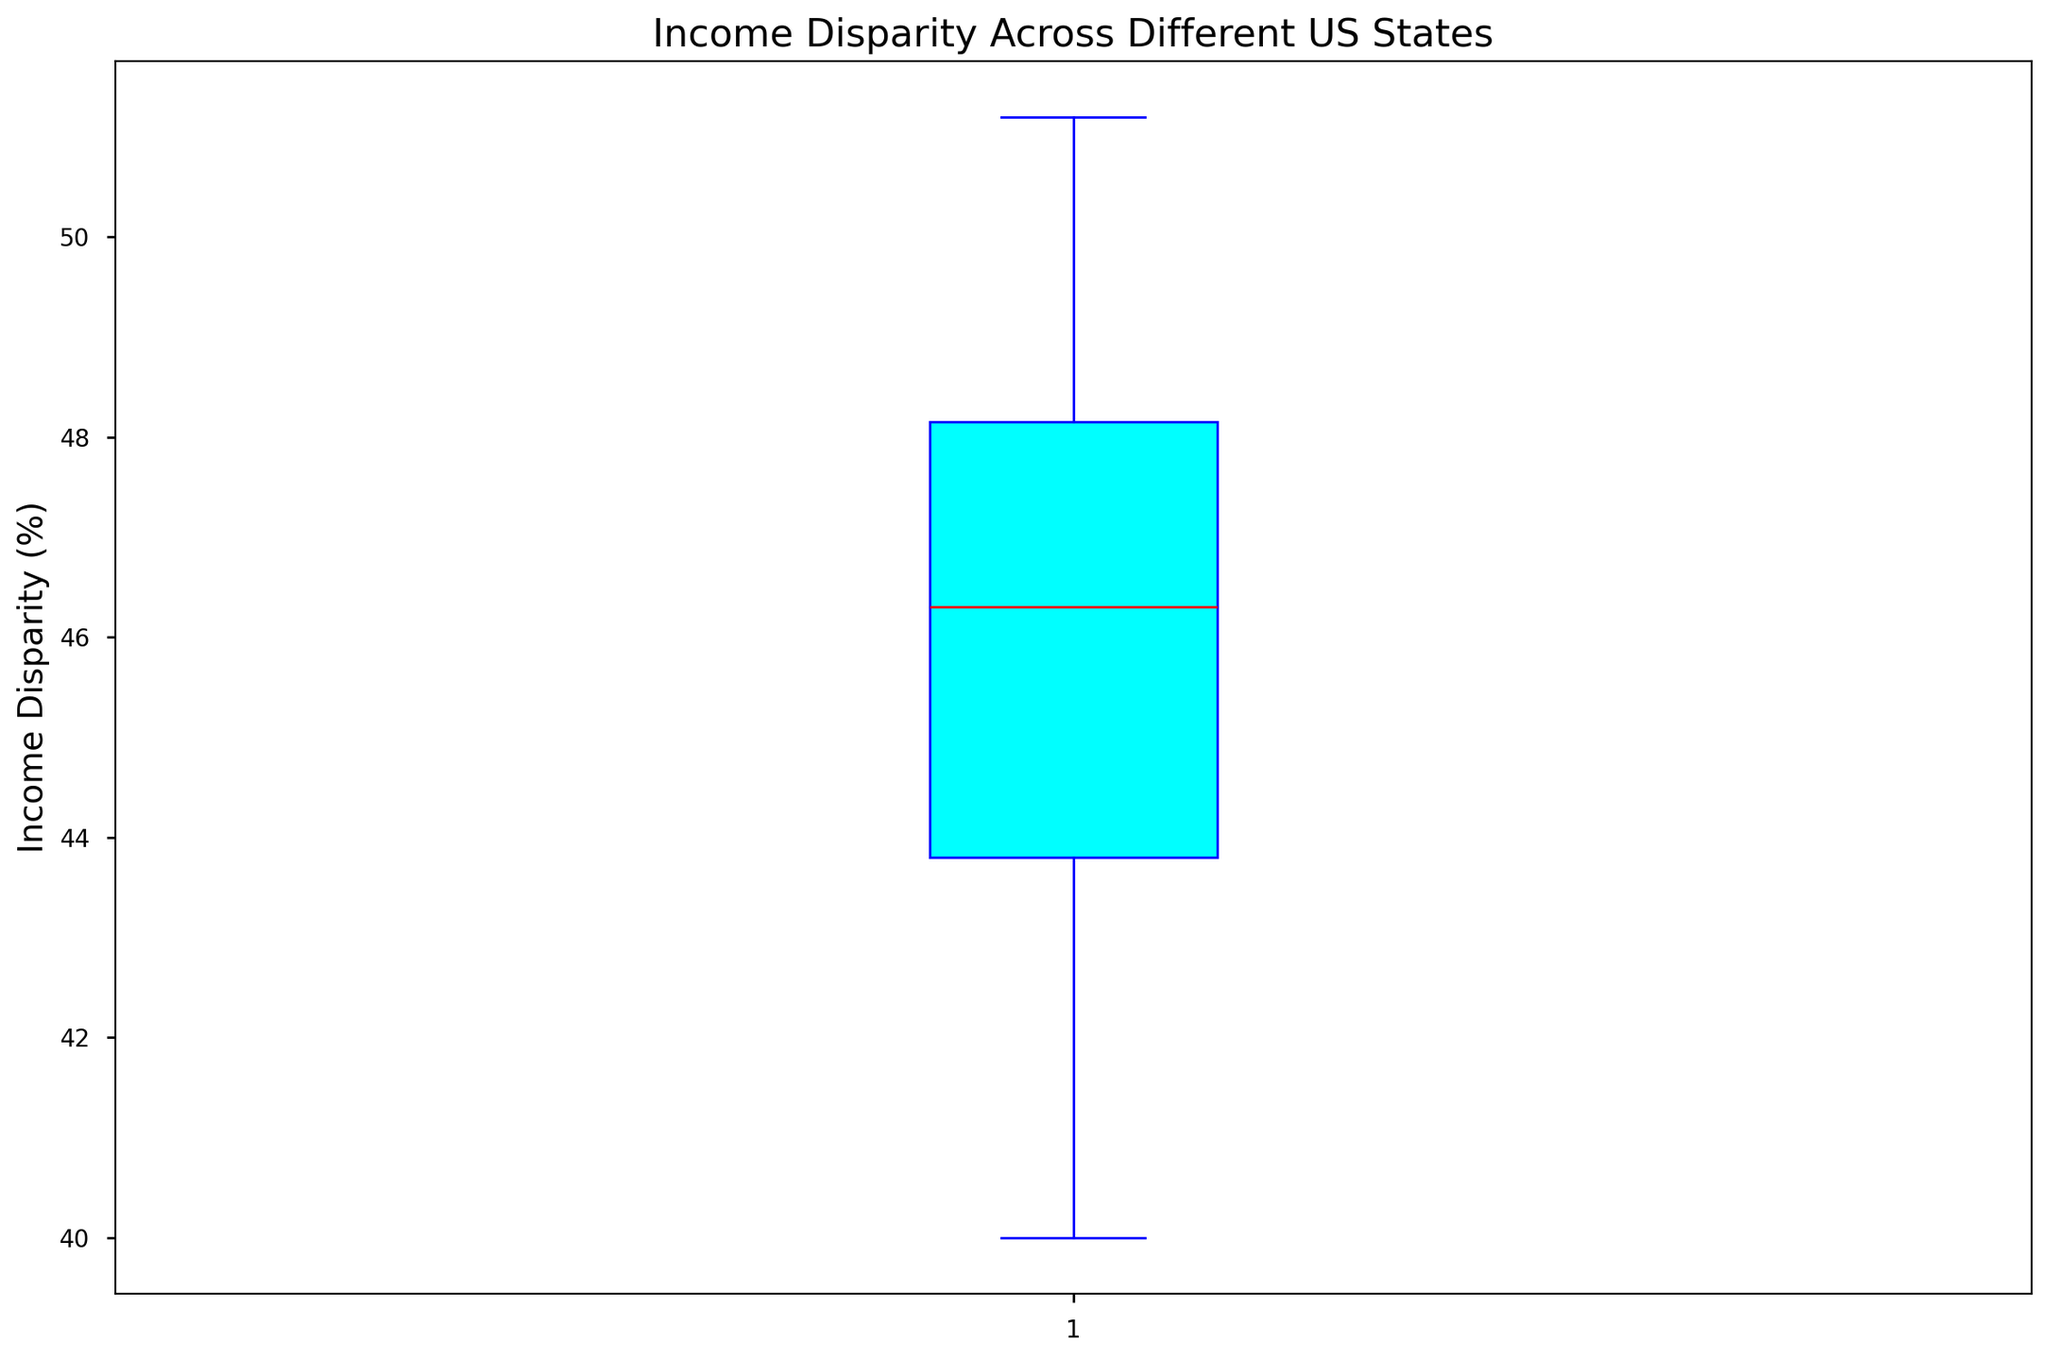Which state has the highest income disparity? The highest income disparity corresponds to the highest point in the box plot. By examining the plot, Mississippi has the highest income disparity.
Answer: Mississippi Which state has the lowest income disparity? The lowest income disparity corresponds to the lowest point in the box plot. By examining the plot, Alaska has the lowest income disparity.
Answer: Alaska What is the median income disparity across the US states? The median value is indicated by the red line within the box of the box plot. The median income disparity is approximately 46.9%.
Answer: 46.9% How does the income disparity in California compare to Texas? By looking at the specific data points, California's income disparity is slightly lower than Texas'. California has an income disparity of 49.2%, while Texas has 49.9%.
Answer: California < Texas Identify the states that have an income disparity above the third quartile. The third quartile is the top of the box (Q3: 48.4%). States with income disparity above this are Connecticut, Louisiana, Mississippi, New York, Texas, and Florida.
Answer: Connecticut, Louisiana, Mississippi, New York, Texas, Florida What is the interquartile range (IQR) for the income disparity across US states? The IQR is calculated as the difference between the third quartile (Q3) and the first quartile (Q1). From the plot, Q3 is approximately 48.4% and Q1 is approximately 43.2%, thus IQR is 48.4% - 43.2% = 5.2%.
Answer: 5.2% Which state's income disparity is closest to the median value? By identifying the point closest to the median in the box plot, Pennsylvania (47.3%) or Kansas (47.4%) are closest to the median value of 46.9%.
Answer: Pennsylvania or Kansas How many states have an income disparity below the first quartile? The first quartile (Q1: 43.2%) marks the lower 25% of the data. States below this value are Alaska, Minnesota, Idaho, Iowa, Vermont, Wyoming, South Dakota.
Answer: 7 states Compare the income disparity of New York and Florida. Which one is higher? By looking at the box plot, New York has an income disparity of 50.6% and Florida has 49.8%, so New York has a higher income disparity than Florida.
Answer: New York > Florida What range of income disparities do the central 50% of the states fall into? The central 50% range is represented by the interquartile range (IQR). From the plot, Q1 is approximately 43.2% and Q3 is approximately 48.4%. Thus, the central 50% of states have income disparities in the range of 43.2% to 48.4%.
Answer: 43.2% to 48.4% 